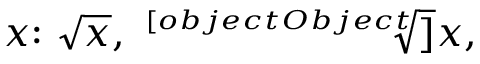Convert formula to latex. <formula><loc_0><loc_0><loc_500><loc_500>x { \colon } { \sqrt { x } } , \ { \sqrt { [ } [ o b j e c t O b j e c t ] ] { x } } ,</formula> 